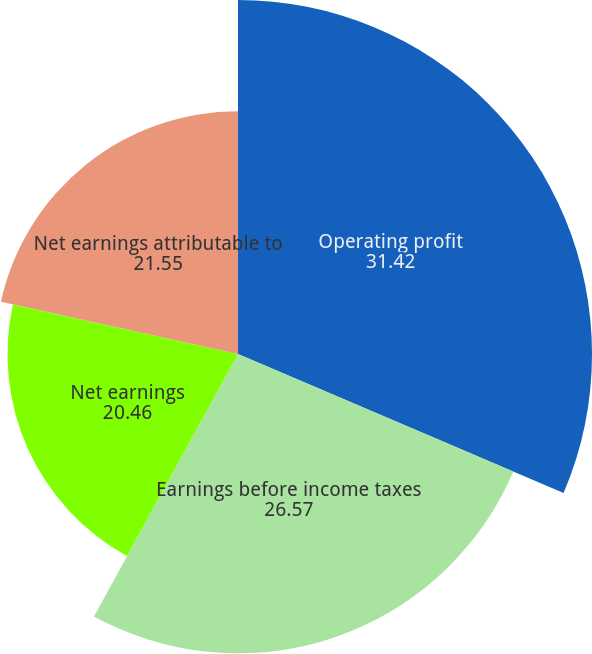Convert chart to OTSL. <chart><loc_0><loc_0><loc_500><loc_500><pie_chart><fcel>Operating profit<fcel>Earnings before income taxes<fcel>Net earnings<fcel>Net earnings attributable to<nl><fcel>31.42%<fcel>26.57%<fcel>20.46%<fcel>21.55%<nl></chart> 